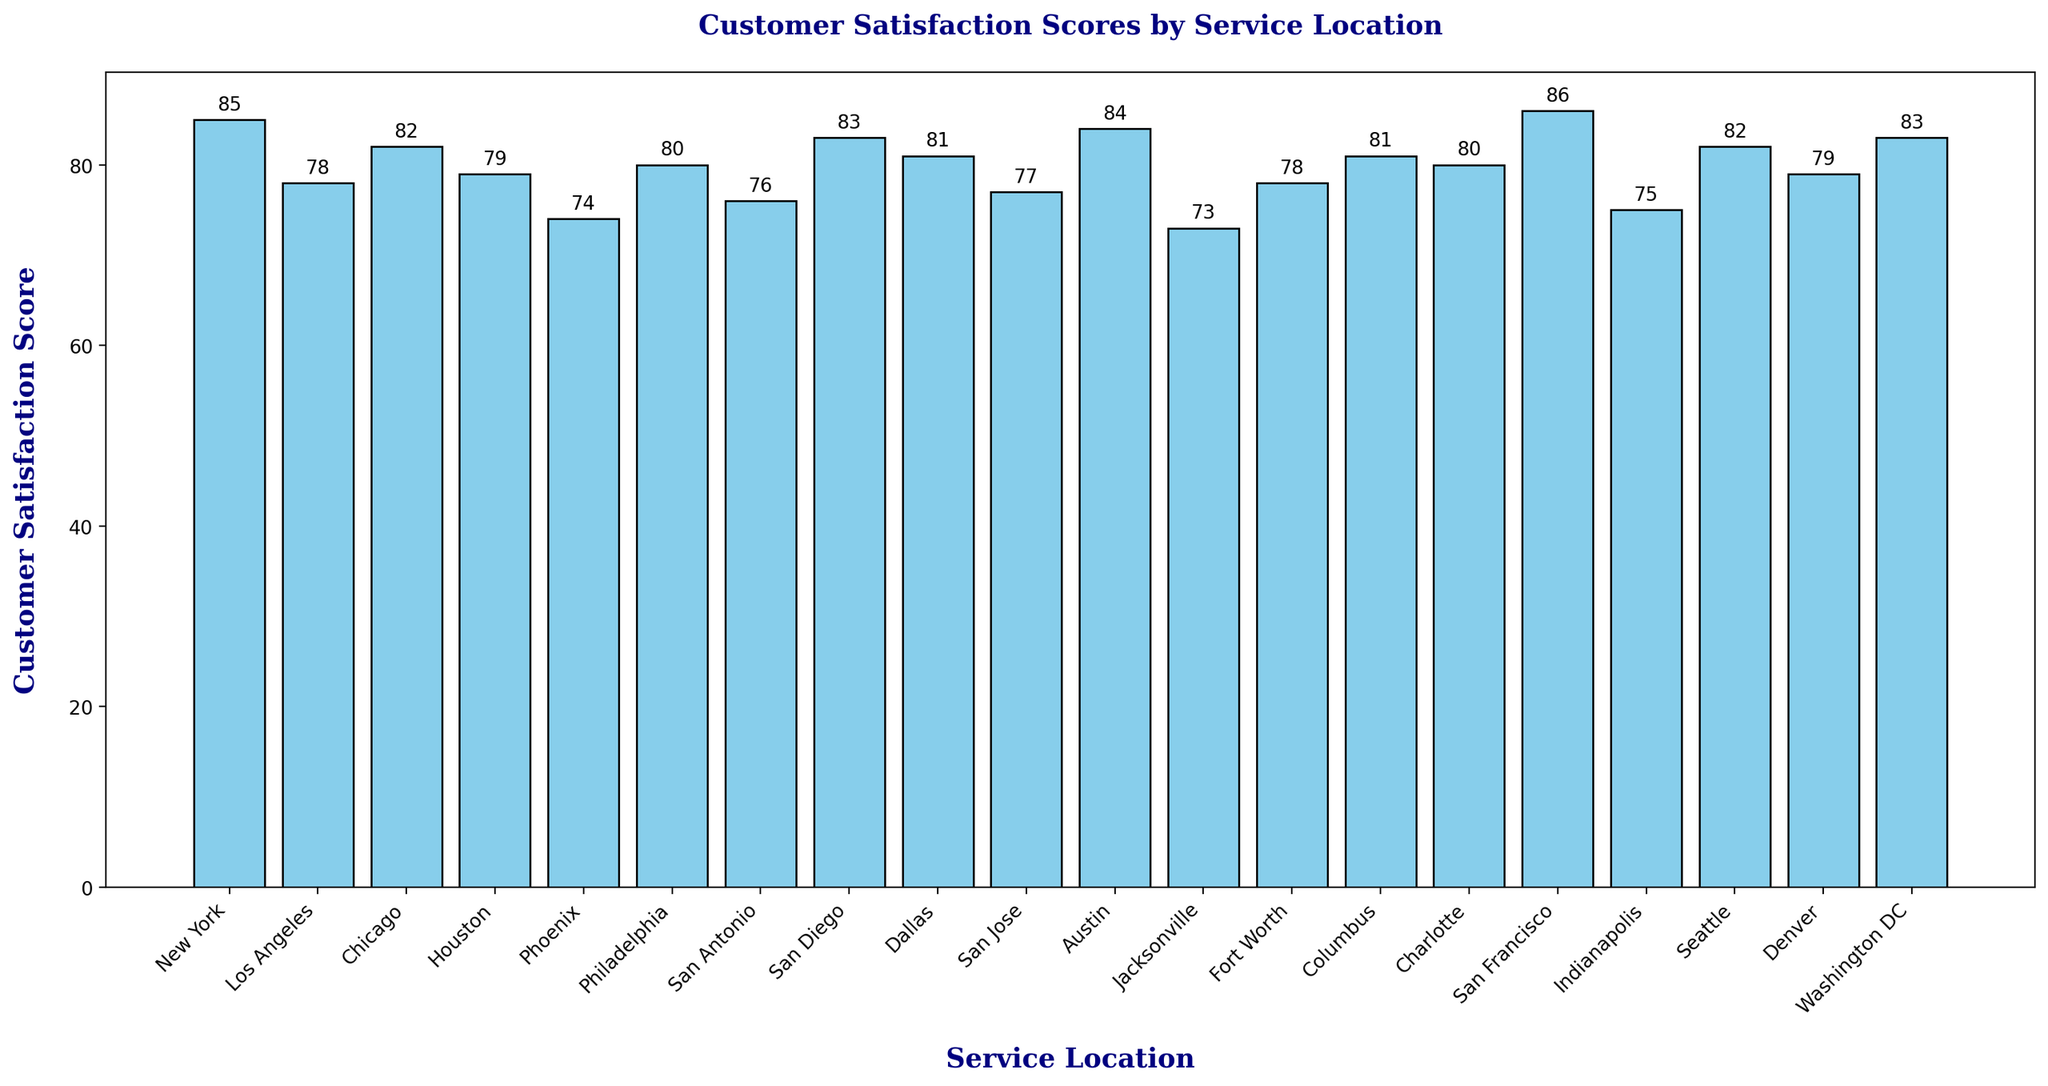What is the customer satisfaction score for New York? Refer to the bar chart and locate the bar labeled "New York". The height of the bar corresponds to the customer satisfaction score.
Answer: 85 Which service location has the highest customer satisfaction score? Locate the bar that reaches the highest point on the y-axis. The label below this bar corresponds to the service location with the highest score.
Answer: San Francisco How many service locations have a satisfaction score of 80 or above? Count the number of bars that reach or exceed the 80 mark on the y-axis.
Answer: 10 What is the difference in customer satisfaction score between Los Angeles and San Jose? Find the heights of the bars labeled "Los Angeles" and "San Jose". Subtract the smaller value from the larger to get the difference. Los Angeles has a score of 78, and San Jose has 77. So, the difference is 78 - 77.
Answer: 1 Which service location has a higher customer satisfaction score, Houston or Denver? Compare the heights of the bars labeled "Houston" and "Denver". The higher bar indicates the higher score.
Answer: Denver What is the average customer satisfaction score for all service locations? Add up all the satisfaction scores, then divide by the number of service locations. The sum is 1581, and there are 20 locations. The average is 1581 / 20.
Answer: 79.05 How does Austin's score compare to the average score? First, calculate the average score as shown above (79.05). Austin's score is 84. Compare 84 to 79.05.
Answer: Higher What is the median customer satisfaction score for the service locations? List all scores in ascending order, then identify the middle value (or average the two middle values if there's an even number of scores). The middle scores are 79 and 80. The median is (79 + 80) / 2.
Answer: 79.5 If aiming to increase all scores below 80 up to exactly 80, how many scores would need to be improved? Count the number of bars with heights below the 80 mark.
Answer: 9 Which service location has the second lowest customer satisfaction score? Find the second shortest bar and note the label beneath it. Jacksonville has the lowest score of 73, and Phoenix has the second lowest of 74.
Answer: Phoenix 